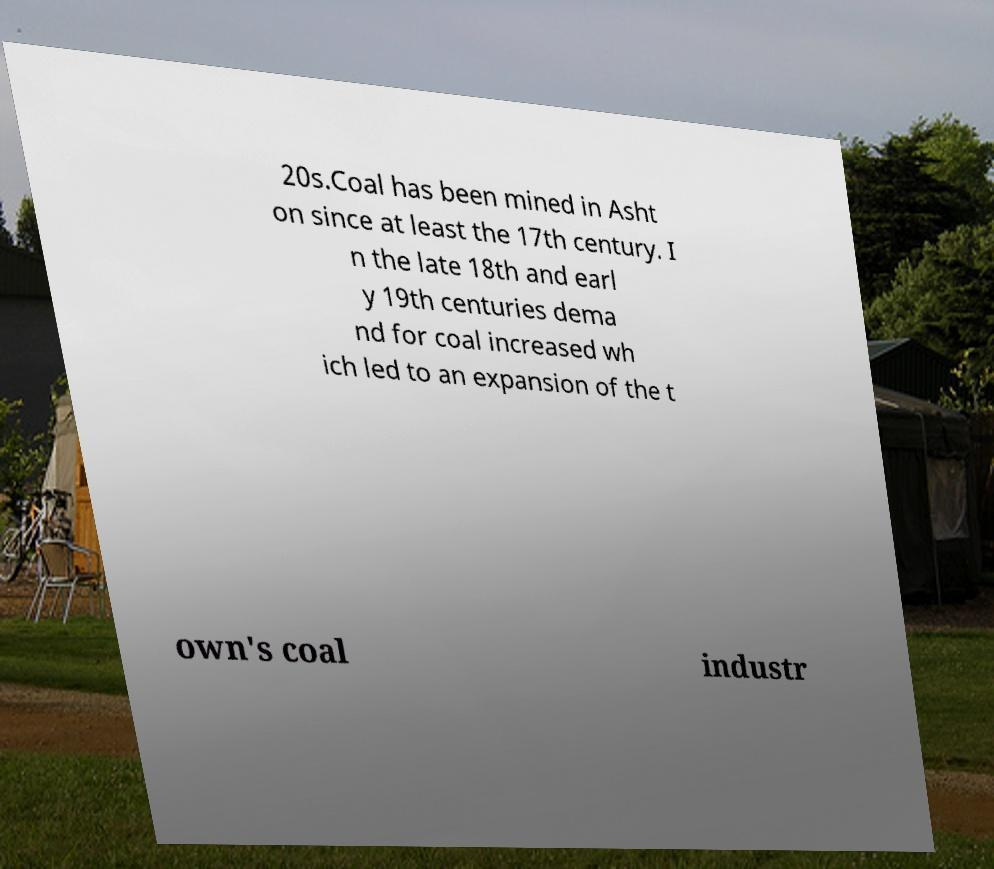What messages or text are displayed in this image? I need them in a readable, typed format. 20s.Coal has been mined in Asht on since at least the 17th century. I n the late 18th and earl y 19th centuries dema nd for coal increased wh ich led to an expansion of the t own's coal industr 